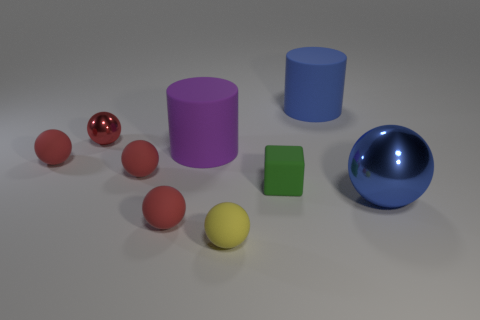Is the small red thing to the left of the tiny metal thing made of the same material as the large blue object in front of the small shiny sphere?
Offer a very short reply. No. What number of things are large objects that are right of the blue cylinder or balls left of the yellow matte sphere?
Your answer should be very brief. 5. Are there any other things that have the same shape as the small green matte thing?
Keep it short and to the point. No. What number of small red things are there?
Your answer should be compact. 4. Are there any other matte cylinders of the same size as the purple matte cylinder?
Provide a succinct answer. Yes. Is the yellow sphere made of the same material as the big blue object that is behind the green rubber object?
Provide a short and direct response. Yes. What is the ball to the right of the small green rubber thing made of?
Make the answer very short. Metal. What is the size of the yellow object?
Your response must be concise. Small. Does the metallic thing on the left side of the purple cylinder have the same size as the red object in front of the cube?
Offer a terse response. Yes. There is a red metallic thing that is the same shape as the yellow matte object; what is its size?
Your answer should be very brief. Small. 